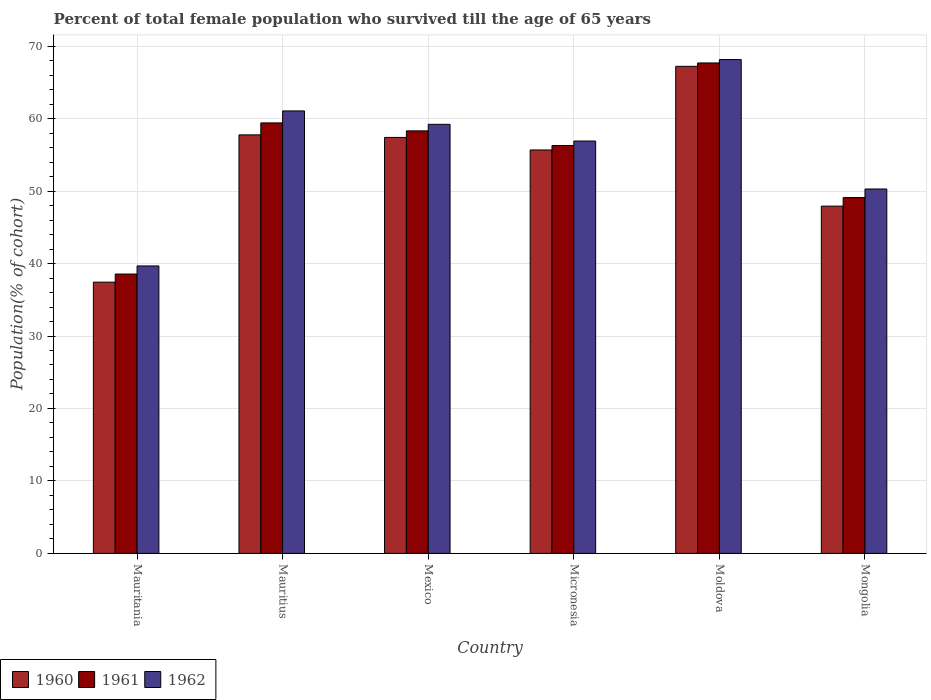How many different coloured bars are there?
Ensure brevity in your answer.  3. Are the number of bars per tick equal to the number of legend labels?
Provide a short and direct response. Yes. Are the number of bars on each tick of the X-axis equal?
Ensure brevity in your answer.  Yes. How many bars are there on the 2nd tick from the left?
Provide a short and direct response. 3. How many bars are there on the 4th tick from the right?
Your answer should be very brief. 3. What is the label of the 2nd group of bars from the left?
Make the answer very short. Mauritius. What is the percentage of total female population who survived till the age of 65 years in 1962 in Micronesia?
Provide a short and direct response. 56.91. Across all countries, what is the maximum percentage of total female population who survived till the age of 65 years in 1960?
Provide a short and direct response. 67.22. Across all countries, what is the minimum percentage of total female population who survived till the age of 65 years in 1962?
Your response must be concise. 39.67. In which country was the percentage of total female population who survived till the age of 65 years in 1962 maximum?
Provide a short and direct response. Moldova. In which country was the percentage of total female population who survived till the age of 65 years in 1960 minimum?
Give a very brief answer. Mauritania. What is the total percentage of total female population who survived till the age of 65 years in 1960 in the graph?
Your response must be concise. 323.41. What is the difference between the percentage of total female population who survived till the age of 65 years in 1962 in Mauritania and that in Mauritius?
Give a very brief answer. -21.39. What is the difference between the percentage of total female population who survived till the age of 65 years in 1961 in Micronesia and the percentage of total female population who survived till the age of 65 years in 1960 in Moldova?
Keep it short and to the point. -10.92. What is the average percentage of total female population who survived till the age of 65 years in 1960 per country?
Make the answer very short. 53.9. What is the difference between the percentage of total female population who survived till the age of 65 years of/in 1960 and percentage of total female population who survived till the age of 65 years of/in 1962 in Moldova?
Give a very brief answer. -0.93. In how many countries, is the percentage of total female population who survived till the age of 65 years in 1962 greater than 28 %?
Ensure brevity in your answer.  6. What is the ratio of the percentage of total female population who survived till the age of 65 years in 1960 in Mexico to that in Moldova?
Provide a short and direct response. 0.85. Is the percentage of total female population who survived till the age of 65 years in 1960 in Mauritania less than that in Mongolia?
Offer a terse response. Yes. What is the difference between the highest and the second highest percentage of total female population who survived till the age of 65 years in 1962?
Keep it short and to the point. -8.94. What is the difference between the highest and the lowest percentage of total female population who survived till the age of 65 years in 1962?
Provide a succinct answer. 28.48. Is the sum of the percentage of total female population who survived till the age of 65 years in 1960 in Mauritius and Mongolia greater than the maximum percentage of total female population who survived till the age of 65 years in 1961 across all countries?
Offer a very short reply. Yes. What does the 2nd bar from the left in Mauritania represents?
Keep it short and to the point. 1961. What does the 1st bar from the right in Moldova represents?
Provide a succinct answer. 1962. Is it the case that in every country, the sum of the percentage of total female population who survived till the age of 65 years in 1961 and percentage of total female population who survived till the age of 65 years in 1962 is greater than the percentage of total female population who survived till the age of 65 years in 1960?
Ensure brevity in your answer.  Yes. Are all the bars in the graph horizontal?
Keep it short and to the point. No. How many countries are there in the graph?
Your answer should be compact. 6. Does the graph contain grids?
Offer a terse response. Yes. How many legend labels are there?
Your answer should be compact. 3. What is the title of the graph?
Offer a terse response. Percent of total female population who survived till the age of 65 years. Does "1986" appear as one of the legend labels in the graph?
Keep it short and to the point. No. What is the label or title of the X-axis?
Your response must be concise. Country. What is the label or title of the Y-axis?
Your response must be concise. Population(% of cohort). What is the Population(% of cohort) in 1960 in Mauritania?
Ensure brevity in your answer.  37.43. What is the Population(% of cohort) of 1961 in Mauritania?
Provide a succinct answer. 38.55. What is the Population(% of cohort) in 1962 in Mauritania?
Ensure brevity in your answer.  39.67. What is the Population(% of cohort) of 1960 in Mauritius?
Your answer should be compact. 57.76. What is the Population(% of cohort) of 1961 in Mauritius?
Make the answer very short. 59.41. What is the Population(% of cohort) of 1962 in Mauritius?
Your answer should be compact. 61.06. What is the Population(% of cohort) in 1960 in Mexico?
Your answer should be compact. 57.4. What is the Population(% of cohort) in 1961 in Mexico?
Offer a terse response. 58.31. What is the Population(% of cohort) in 1962 in Mexico?
Give a very brief answer. 59.22. What is the Population(% of cohort) in 1960 in Micronesia?
Offer a terse response. 55.67. What is the Population(% of cohort) of 1961 in Micronesia?
Provide a short and direct response. 56.29. What is the Population(% of cohort) of 1962 in Micronesia?
Make the answer very short. 56.91. What is the Population(% of cohort) in 1960 in Moldova?
Make the answer very short. 67.22. What is the Population(% of cohort) of 1961 in Moldova?
Make the answer very short. 67.68. What is the Population(% of cohort) of 1962 in Moldova?
Offer a terse response. 68.15. What is the Population(% of cohort) of 1960 in Mongolia?
Offer a very short reply. 47.92. What is the Population(% of cohort) in 1961 in Mongolia?
Make the answer very short. 49.11. What is the Population(% of cohort) of 1962 in Mongolia?
Provide a succinct answer. 50.29. Across all countries, what is the maximum Population(% of cohort) in 1960?
Make the answer very short. 67.22. Across all countries, what is the maximum Population(% of cohort) in 1961?
Provide a succinct answer. 67.68. Across all countries, what is the maximum Population(% of cohort) of 1962?
Ensure brevity in your answer.  68.15. Across all countries, what is the minimum Population(% of cohort) in 1960?
Offer a terse response. 37.43. Across all countries, what is the minimum Population(% of cohort) in 1961?
Provide a succinct answer. 38.55. Across all countries, what is the minimum Population(% of cohort) of 1962?
Your answer should be compact. 39.67. What is the total Population(% of cohort) of 1960 in the graph?
Keep it short and to the point. 323.41. What is the total Population(% of cohort) in 1961 in the graph?
Provide a short and direct response. 329.35. What is the total Population(% of cohort) of 1962 in the graph?
Your answer should be very brief. 335.3. What is the difference between the Population(% of cohort) in 1960 in Mauritania and that in Mauritius?
Ensure brevity in your answer.  -20.32. What is the difference between the Population(% of cohort) in 1961 in Mauritania and that in Mauritius?
Offer a very short reply. -20.86. What is the difference between the Population(% of cohort) of 1962 in Mauritania and that in Mauritius?
Keep it short and to the point. -21.39. What is the difference between the Population(% of cohort) of 1960 in Mauritania and that in Mexico?
Offer a very short reply. -19.97. What is the difference between the Population(% of cohort) in 1961 in Mauritania and that in Mexico?
Offer a very short reply. -19.76. What is the difference between the Population(% of cohort) in 1962 in Mauritania and that in Mexico?
Your response must be concise. -19.55. What is the difference between the Population(% of cohort) of 1960 in Mauritania and that in Micronesia?
Make the answer very short. -18.24. What is the difference between the Population(% of cohort) of 1961 in Mauritania and that in Micronesia?
Give a very brief answer. -17.74. What is the difference between the Population(% of cohort) in 1962 in Mauritania and that in Micronesia?
Provide a short and direct response. -17.24. What is the difference between the Population(% of cohort) in 1960 in Mauritania and that in Moldova?
Ensure brevity in your answer.  -29.78. What is the difference between the Population(% of cohort) in 1961 in Mauritania and that in Moldova?
Your answer should be compact. -29.13. What is the difference between the Population(% of cohort) of 1962 in Mauritania and that in Moldova?
Your answer should be compact. -28.48. What is the difference between the Population(% of cohort) of 1960 in Mauritania and that in Mongolia?
Ensure brevity in your answer.  -10.49. What is the difference between the Population(% of cohort) in 1961 in Mauritania and that in Mongolia?
Provide a succinct answer. -10.56. What is the difference between the Population(% of cohort) in 1962 in Mauritania and that in Mongolia?
Give a very brief answer. -10.62. What is the difference between the Population(% of cohort) in 1960 in Mauritius and that in Mexico?
Your response must be concise. 0.35. What is the difference between the Population(% of cohort) in 1961 in Mauritius and that in Mexico?
Your answer should be compact. 1.1. What is the difference between the Population(% of cohort) of 1962 in Mauritius and that in Mexico?
Provide a succinct answer. 1.85. What is the difference between the Population(% of cohort) of 1960 in Mauritius and that in Micronesia?
Your answer should be very brief. 2.08. What is the difference between the Population(% of cohort) of 1961 in Mauritius and that in Micronesia?
Your response must be concise. 3.12. What is the difference between the Population(% of cohort) in 1962 in Mauritius and that in Micronesia?
Provide a succinct answer. 4.15. What is the difference between the Population(% of cohort) of 1960 in Mauritius and that in Moldova?
Offer a terse response. -9.46. What is the difference between the Population(% of cohort) in 1961 in Mauritius and that in Moldova?
Provide a short and direct response. -8.27. What is the difference between the Population(% of cohort) of 1962 in Mauritius and that in Moldova?
Ensure brevity in your answer.  -7.09. What is the difference between the Population(% of cohort) in 1960 in Mauritius and that in Mongolia?
Your answer should be very brief. 9.83. What is the difference between the Population(% of cohort) of 1961 in Mauritius and that in Mongolia?
Your answer should be very brief. 10.3. What is the difference between the Population(% of cohort) of 1962 in Mauritius and that in Mongolia?
Provide a succinct answer. 10.77. What is the difference between the Population(% of cohort) of 1960 in Mexico and that in Micronesia?
Ensure brevity in your answer.  1.73. What is the difference between the Population(% of cohort) of 1961 in Mexico and that in Micronesia?
Offer a very short reply. 2.02. What is the difference between the Population(% of cohort) in 1962 in Mexico and that in Micronesia?
Make the answer very short. 2.31. What is the difference between the Population(% of cohort) in 1960 in Mexico and that in Moldova?
Provide a succinct answer. -9.81. What is the difference between the Population(% of cohort) of 1961 in Mexico and that in Moldova?
Ensure brevity in your answer.  -9.37. What is the difference between the Population(% of cohort) in 1962 in Mexico and that in Moldova?
Ensure brevity in your answer.  -8.94. What is the difference between the Population(% of cohort) of 1960 in Mexico and that in Mongolia?
Give a very brief answer. 9.48. What is the difference between the Population(% of cohort) of 1961 in Mexico and that in Mongolia?
Ensure brevity in your answer.  9.2. What is the difference between the Population(% of cohort) in 1962 in Mexico and that in Mongolia?
Provide a succinct answer. 8.93. What is the difference between the Population(% of cohort) of 1960 in Micronesia and that in Moldova?
Make the answer very short. -11.54. What is the difference between the Population(% of cohort) in 1961 in Micronesia and that in Moldova?
Your answer should be very brief. -11.39. What is the difference between the Population(% of cohort) of 1962 in Micronesia and that in Moldova?
Provide a short and direct response. -11.24. What is the difference between the Population(% of cohort) of 1960 in Micronesia and that in Mongolia?
Your response must be concise. 7.75. What is the difference between the Population(% of cohort) of 1961 in Micronesia and that in Mongolia?
Your response must be concise. 7.19. What is the difference between the Population(% of cohort) in 1962 in Micronesia and that in Mongolia?
Provide a short and direct response. 6.62. What is the difference between the Population(% of cohort) of 1960 in Moldova and that in Mongolia?
Your response must be concise. 19.29. What is the difference between the Population(% of cohort) of 1961 in Moldova and that in Mongolia?
Offer a terse response. 18.58. What is the difference between the Population(% of cohort) of 1962 in Moldova and that in Mongolia?
Your response must be concise. 17.86. What is the difference between the Population(% of cohort) in 1960 in Mauritania and the Population(% of cohort) in 1961 in Mauritius?
Give a very brief answer. -21.98. What is the difference between the Population(% of cohort) of 1960 in Mauritania and the Population(% of cohort) of 1962 in Mauritius?
Your answer should be compact. -23.63. What is the difference between the Population(% of cohort) in 1961 in Mauritania and the Population(% of cohort) in 1962 in Mauritius?
Your answer should be very brief. -22.51. What is the difference between the Population(% of cohort) of 1960 in Mauritania and the Population(% of cohort) of 1961 in Mexico?
Ensure brevity in your answer.  -20.88. What is the difference between the Population(% of cohort) of 1960 in Mauritania and the Population(% of cohort) of 1962 in Mexico?
Your answer should be compact. -21.78. What is the difference between the Population(% of cohort) of 1961 in Mauritania and the Population(% of cohort) of 1962 in Mexico?
Ensure brevity in your answer.  -20.66. What is the difference between the Population(% of cohort) in 1960 in Mauritania and the Population(% of cohort) in 1961 in Micronesia?
Give a very brief answer. -18.86. What is the difference between the Population(% of cohort) in 1960 in Mauritania and the Population(% of cohort) in 1962 in Micronesia?
Your answer should be compact. -19.48. What is the difference between the Population(% of cohort) in 1961 in Mauritania and the Population(% of cohort) in 1962 in Micronesia?
Your response must be concise. -18.36. What is the difference between the Population(% of cohort) of 1960 in Mauritania and the Population(% of cohort) of 1961 in Moldova?
Make the answer very short. -30.25. What is the difference between the Population(% of cohort) of 1960 in Mauritania and the Population(% of cohort) of 1962 in Moldova?
Offer a very short reply. -30.72. What is the difference between the Population(% of cohort) of 1961 in Mauritania and the Population(% of cohort) of 1962 in Moldova?
Offer a very short reply. -29.6. What is the difference between the Population(% of cohort) in 1960 in Mauritania and the Population(% of cohort) in 1961 in Mongolia?
Make the answer very short. -11.67. What is the difference between the Population(% of cohort) of 1960 in Mauritania and the Population(% of cohort) of 1962 in Mongolia?
Give a very brief answer. -12.86. What is the difference between the Population(% of cohort) of 1961 in Mauritania and the Population(% of cohort) of 1962 in Mongolia?
Give a very brief answer. -11.74. What is the difference between the Population(% of cohort) of 1960 in Mauritius and the Population(% of cohort) of 1961 in Mexico?
Offer a very short reply. -0.55. What is the difference between the Population(% of cohort) in 1960 in Mauritius and the Population(% of cohort) in 1962 in Mexico?
Provide a short and direct response. -1.46. What is the difference between the Population(% of cohort) of 1961 in Mauritius and the Population(% of cohort) of 1962 in Mexico?
Ensure brevity in your answer.  0.2. What is the difference between the Population(% of cohort) in 1960 in Mauritius and the Population(% of cohort) in 1961 in Micronesia?
Give a very brief answer. 1.47. What is the difference between the Population(% of cohort) of 1960 in Mauritius and the Population(% of cohort) of 1962 in Micronesia?
Your response must be concise. 0.85. What is the difference between the Population(% of cohort) of 1961 in Mauritius and the Population(% of cohort) of 1962 in Micronesia?
Keep it short and to the point. 2.5. What is the difference between the Population(% of cohort) of 1960 in Mauritius and the Population(% of cohort) of 1961 in Moldova?
Provide a succinct answer. -9.93. What is the difference between the Population(% of cohort) of 1960 in Mauritius and the Population(% of cohort) of 1962 in Moldova?
Keep it short and to the point. -10.39. What is the difference between the Population(% of cohort) of 1961 in Mauritius and the Population(% of cohort) of 1962 in Moldova?
Provide a succinct answer. -8.74. What is the difference between the Population(% of cohort) in 1960 in Mauritius and the Population(% of cohort) in 1961 in Mongolia?
Make the answer very short. 8.65. What is the difference between the Population(% of cohort) in 1960 in Mauritius and the Population(% of cohort) in 1962 in Mongolia?
Make the answer very short. 7.47. What is the difference between the Population(% of cohort) in 1961 in Mauritius and the Population(% of cohort) in 1962 in Mongolia?
Ensure brevity in your answer.  9.12. What is the difference between the Population(% of cohort) in 1960 in Mexico and the Population(% of cohort) in 1961 in Micronesia?
Offer a terse response. 1.11. What is the difference between the Population(% of cohort) of 1960 in Mexico and the Population(% of cohort) of 1962 in Micronesia?
Give a very brief answer. 0.49. What is the difference between the Population(% of cohort) in 1961 in Mexico and the Population(% of cohort) in 1962 in Micronesia?
Provide a succinct answer. 1.4. What is the difference between the Population(% of cohort) of 1960 in Mexico and the Population(% of cohort) of 1961 in Moldova?
Your answer should be compact. -10.28. What is the difference between the Population(% of cohort) in 1960 in Mexico and the Population(% of cohort) in 1962 in Moldova?
Your answer should be compact. -10.75. What is the difference between the Population(% of cohort) in 1961 in Mexico and the Population(% of cohort) in 1962 in Moldova?
Keep it short and to the point. -9.84. What is the difference between the Population(% of cohort) in 1960 in Mexico and the Population(% of cohort) in 1961 in Mongolia?
Make the answer very short. 8.3. What is the difference between the Population(% of cohort) in 1960 in Mexico and the Population(% of cohort) in 1962 in Mongolia?
Offer a terse response. 7.11. What is the difference between the Population(% of cohort) in 1961 in Mexico and the Population(% of cohort) in 1962 in Mongolia?
Ensure brevity in your answer.  8.02. What is the difference between the Population(% of cohort) of 1960 in Micronesia and the Population(% of cohort) of 1961 in Moldova?
Ensure brevity in your answer.  -12.01. What is the difference between the Population(% of cohort) in 1960 in Micronesia and the Population(% of cohort) in 1962 in Moldova?
Keep it short and to the point. -12.48. What is the difference between the Population(% of cohort) of 1961 in Micronesia and the Population(% of cohort) of 1962 in Moldova?
Offer a terse response. -11.86. What is the difference between the Population(% of cohort) of 1960 in Micronesia and the Population(% of cohort) of 1961 in Mongolia?
Your response must be concise. 6.57. What is the difference between the Population(% of cohort) of 1960 in Micronesia and the Population(% of cohort) of 1962 in Mongolia?
Your response must be concise. 5.39. What is the difference between the Population(% of cohort) of 1961 in Micronesia and the Population(% of cohort) of 1962 in Mongolia?
Give a very brief answer. 6. What is the difference between the Population(% of cohort) in 1960 in Moldova and the Population(% of cohort) in 1961 in Mongolia?
Keep it short and to the point. 18.11. What is the difference between the Population(% of cohort) in 1960 in Moldova and the Population(% of cohort) in 1962 in Mongolia?
Keep it short and to the point. 16.93. What is the difference between the Population(% of cohort) in 1961 in Moldova and the Population(% of cohort) in 1962 in Mongolia?
Ensure brevity in your answer.  17.39. What is the average Population(% of cohort) of 1960 per country?
Offer a very short reply. 53.9. What is the average Population(% of cohort) in 1961 per country?
Offer a terse response. 54.89. What is the average Population(% of cohort) in 1962 per country?
Make the answer very short. 55.88. What is the difference between the Population(% of cohort) of 1960 and Population(% of cohort) of 1961 in Mauritania?
Your answer should be compact. -1.12. What is the difference between the Population(% of cohort) of 1960 and Population(% of cohort) of 1962 in Mauritania?
Offer a terse response. -2.24. What is the difference between the Population(% of cohort) of 1961 and Population(% of cohort) of 1962 in Mauritania?
Offer a terse response. -1.12. What is the difference between the Population(% of cohort) in 1960 and Population(% of cohort) in 1961 in Mauritius?
Provide a short and direct response. -1.65. What is the difference between the Population(% of cohort) of 1960 and Population(% of cohort) of 1962 in Mauritius?
Keep it short and to the point. -3.31. What is the difference between the Population(% of cohort) in 1961 and Population(% of cohort) in 1962 in Mauritius?
Your answer should be compact. -1.65. What is the difference between the Population(% of cohort) of 1960 and Population(% of cohort) of 1961 in Mexico?
Your answer should be very brief. -0.91. What is the difference between the Population(% of cohort) of 1960 and Population(% of cohort) of 1962 in Mexico?
Your answer should be very brief. -1.81. What is the difference between the Population(% of cohort) in 1961 and Population(% of cohort) in 1962 in Mexico?
Keep it short and to the point. -0.91. What is the difference between the Population(% of cohort) of 1960 and Population(% of cohort) of 1961 in Micronesia?
Offer a terse response. -0.62. What is the difference between the Population(% of cohort) in 1960 and Population(% of cohort) in 1962 in Micronesia?
Provide a short and direct response. -1.23. What is the difference between the Population(% of cohort) in 1961 and Population(% of cohort) in 1962 in Micronesia?
Give a very brief answer. -0.62. What is the difference between the Population(% of cohort) in 1960 and Population(% of cohort) in 1961 in Moldova?
Provide a short and direct response. -0.47. What is the difference between the Population(% of cohort) in 1960 and Population(% of cohort) in 1962 in Moldova?
Provide a short and direct response. -0.93. What is the difference between the Population(% of cohort) in 1961 and Population(% of cohort) in 1962 in Moldova?
Give a very brief answer. -0.47. What is the difference between the Population(% of cohort) in 1960 and Population(% of cohort) in 1961 in Mongolia?
Ensure brevity in your answer.  -1.18. What is the difference between the Population(% of cohort) in 1960 and Population(% of cohort) in 1962 in Mongolia?
Your answer should be compact. -2.36. What is the difference between the Population(% of cohort) of 1961 and Population(% of cohort) of 1962 in Mongolia?
Your answer should be compact. -1.18. What is the ratio of the Population(% of cohort) in 1960 in Mauritania to that in Mauritius?
Make the answer very short. 0.65. What is the ratio of the Population(% of cohort) of 1961 in Mauritania to that in Mauritius?
Offer a terse response. 0.65. What is the ratio of the Population(% of cohort) in 1962 in Mauritania to that in Mauritius?
Keep it short and to the point. 0.65. What is the ratio of the Population(% of cohort) of 1960 in Mauritania to that in Mexico?
Provide a succinct answer. 0.65. What is the ratio of the Population(% of cohort) in 1961 in Mauritania to that in Mexico?
Offer a terse response. 0.66. What is the ratio of the Population(% of cohort) of 1962 in Mauritania to that in Mexico?
Provide a short and direct response. 0.67. What is the ratio of the Population(% of cohort) in 1960 in Mauritania to that in Micronesia?
Provide a short and direct response. 0.67. What is the ratio of the Population(% of cohort) in 1961 in Mauritania to that in Micronesia?
Your answer should be compact. 0.68. What is the ratio of the Population(% of cohort) in 1962 in Mauritania to that in Micronesia?
Offer a terse response. 0.7. What is the ratio of the Population(% of cohort) of 1960 in Mauritania to that in Moldova?
Provide a short and direct response. 0.56. What is the ratio of the Population(% of cohort) of 1961 in Mauritania to that in Moldova?
Your response must be concise. 0.57. What is the ratio of the Population(% of cohort) in 1962 in Mauritania to that in Moldova?
Your answer should be compact. 0.58. What is the ratio of the Population(% of cohort) of 1960 in Mauritania to that in Mongolia?
Provide a short and direct response. 0.78. What is the ratio of the Population(% of cohort) in 1961 in Mauritania to that in Mongolia?
Offer a terse response. 0.79. What is the ratio of the Population(% of cohort) in 1962 in Mauritania to that in Mongolia?
Your response must be concise. 0.79. What is the ratio of the Population(% of cohort) in 1960 in Mauritius to that in Mexico?
Make the answer very short. 1.01. What is the ratio of the Population(% of cohort) of 1961 in Mauritius to that in Mexico?
Offer a very short reply. 1.02. What is the ratio of the Population(% of cohort) in 1962 in Mauritius to that in Mexico?
Ensure brevity in your answer.  1.03. What is the ratio of the Population(% of cohort) in 1960 in Mauritius to that in Micronesia?
Your response must be concise. 1.04. What is the ratio of the Population(% of cohort) in 1961 in Mauritius to that in Micronesia?
Offer a terse response. 1.06. What is the ratio of the Population(% of cohort) in 1962 in Mauritius to that in Micronesia?
Give a very brief answer. 1.07. What is the ratio of the Population(% of cohort) in 1960 in Mauritius to that in Moldova?
Give a very brief answer. 0.86. What is the ratio of the Population(% of cohort) in 1961 in Mauritius to that in Moldova?
Give a very brief answer. 0.88. What is the ratio of the Population(% of cohort) in 1962 in Mauritius to that in Moldova?
Ensure brevity in your answer.  0.9. What is the ratio of the Population(% of cohort) in 1960 in Mauritius to that in Mongolia?
Offer a terse response. 1.21. What is the ratio of the Population(% of cohort) in 1961 in Mauritius to that in Mongolia?
Provide a succinct answer. 1.21. What is the ratio of the Population(% of cohort) in 1962 in Mauritius to that in Mongolia?
Ensure brevity in your answer.  1.21. What is the ratio of the Population(% of cohort) of 1960 in Mexico to that in Micronesia?
Your response must be concise. 1.03. What is the ratio of the Population(% of cohort) in 1961 in Mexico to that in Micronesia?
Offer a very short reply. 1.04. What is the ratio of the Population(% of cohort) in 1962 in Mexico to that in Micronesia?
Offer a very short reply. 1.04. What is the ratio of the Population(% of cohort) of 1960 in Mexico to that in Moldova?
Your answer should be compact. 0.85. What is the ratio of the Population(% of cohort) of 1961 in Mexico to that in Moldova?
Provide a short and direct response. 0.86. What is the ratio of the Population(% of cohort) in 1962 in Mexico to that in Moldova?
Keep it short and to the point. 0.87. What is the ratio of the Population(% of cohort) in 1960 in Mexico to that in Mongolia?
Make the answer very short. 1.2. What is the ratio of the Population(% of cohort) in 1961 in Mexico to that in Mongolia?
Your answer should be compact. 1.19. What is the ratio of the Population(% of cohort) in 1962 in Mexico to that in Mongolia?
Your answer should be very brief. 1.18. What is the ratio of the Population(% of cohort) of 1960 in Micronesia to that in Moldova?
Your answer should be very brief. 0.83. What is the ratio of the Population(% of cohort) in 1961 in Micronesia to that in Moldova?
Make the answer very short. 0.83. What is the ratio of the Population(% of cohort) of 1962 in Micronesia to that in Moldova?
Your answer should be very brief. 0.84. What is the ratio of the Population(% of cohort) of 1960 in Micronesia to that in Mongolia?
Make the answer very short. 1.16. What is the ratio of the Population(% of cohort) of 1961 in Micronesia to that in Mongolia?
Your answer should be compact. 1.15. What is the ratio of the Population(% of cohort) of 1962 in Micronesia to that in Mongolia?
Make the answer very short. 1.13. What is the ratio of the Population(% of cohort) of 1960 in Moldova to that in Mongolia?
Offer a very short reply. 1.4. What is the ratio of the Population(% of cohort) of 1961 in Moldova to that in Mongolia?
Keep it short and to the point. 1.38. What is the ratio of the Population(% of cohort) in 1962 in Moldova to that in Mongolia?
Ensure brevity in your answer.  1.36. What is the difference between the highest and the second highest Population(% of cohort) in 1960?
Provide a short and direct response. 9.46. What is the difference between the highest and the second highest Population(% of cohort) of 1961?
Your answer should be compact. 8.27. What is the difference between the highest and the second highest Population(% of cohort) of 1962?
Give a very brief answer. 7.09. What is the difference between the highest and the lowest Population(% of cohort) of 1960?
Ensure brevity in your answer.  29.78. What is the difference between the highest and the lowest Population(% of cohort) of 1961?
Ensure brevity in your answer.  29.13. What is the difference between the highest and the lowest Population(% of cohort) in 1962?
Give a very brief answer. 28.48. 